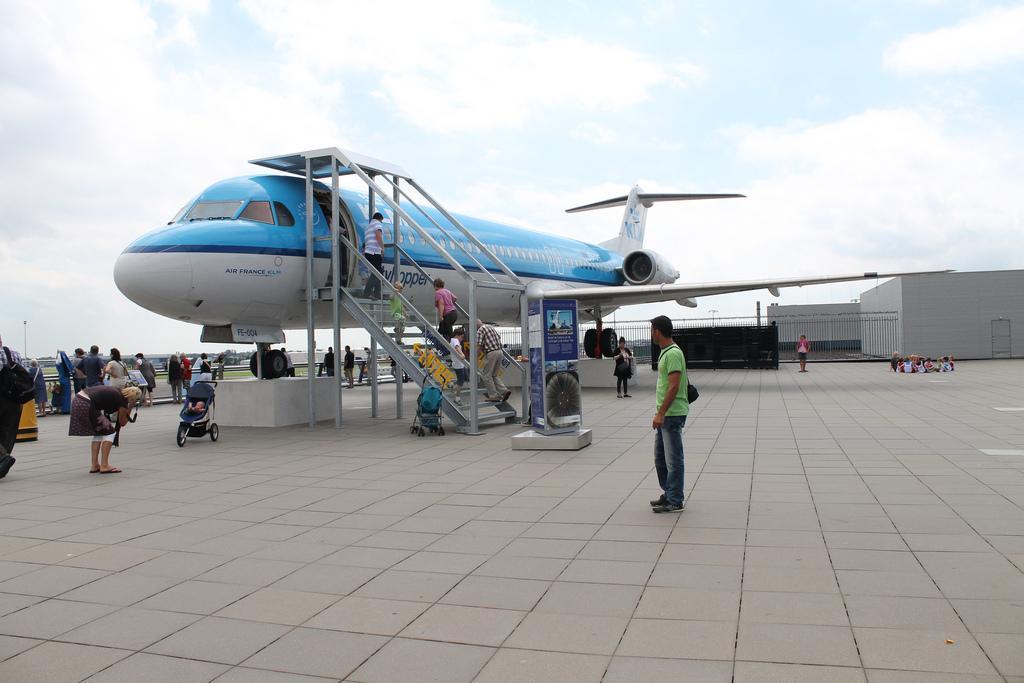How many people are on the stairs?
Give a very brief answer. 6. How many babies are there in the picture?
Give a very brief answer. 1. 